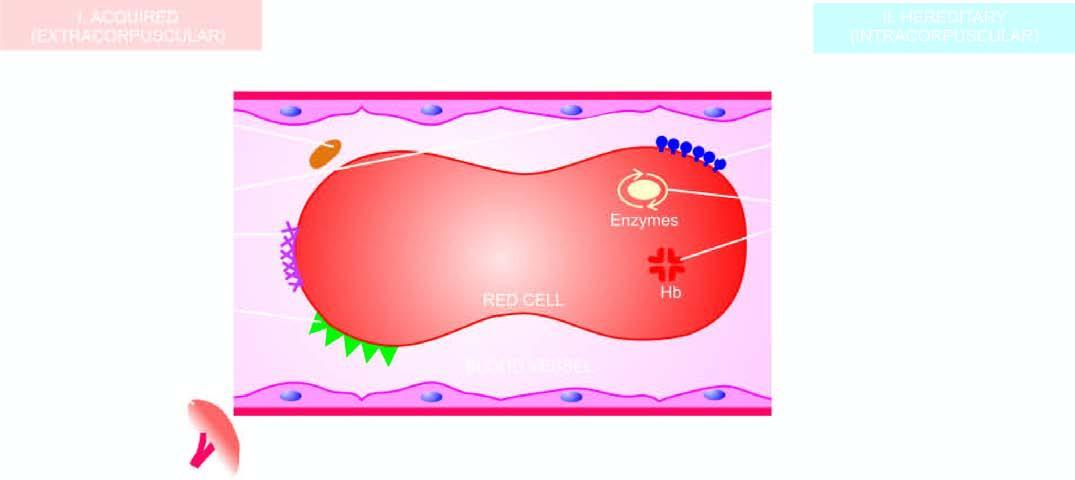what is based on principal mechanisms of haemolysis?
Answer the question using a single word or phrase. Diagrammatic representation of classification of haemolytic anaemias haemolysis 